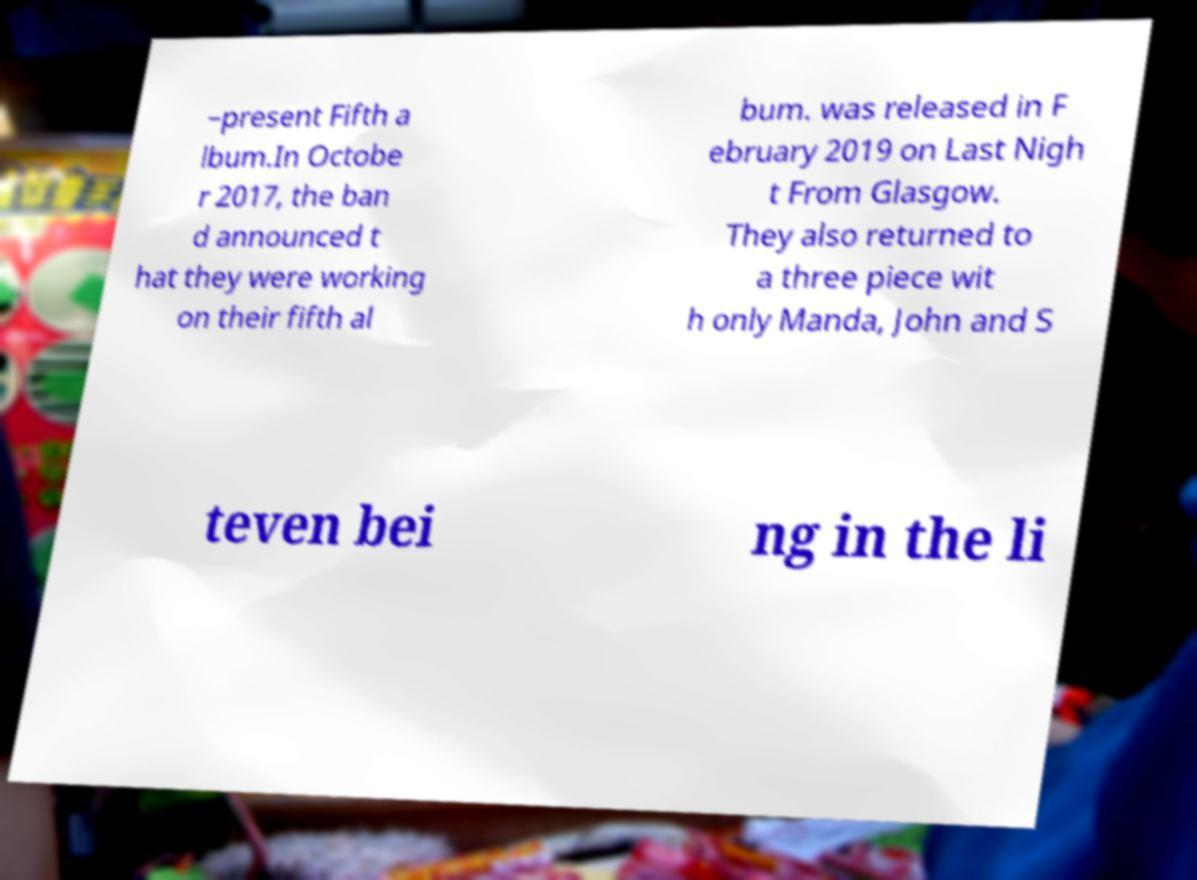For documentation purposes, I need the text within this image transcribed. Could you provide that? –present Fifth a lbum.In Octobe r 2017, the ban d announced t hat they were working on their fifth al bum. was released in F ebruary 2019 on Last Nigh t From Glasgow. They also returned to a three piece wit h only Manda, John and S teven bei ng in the li 